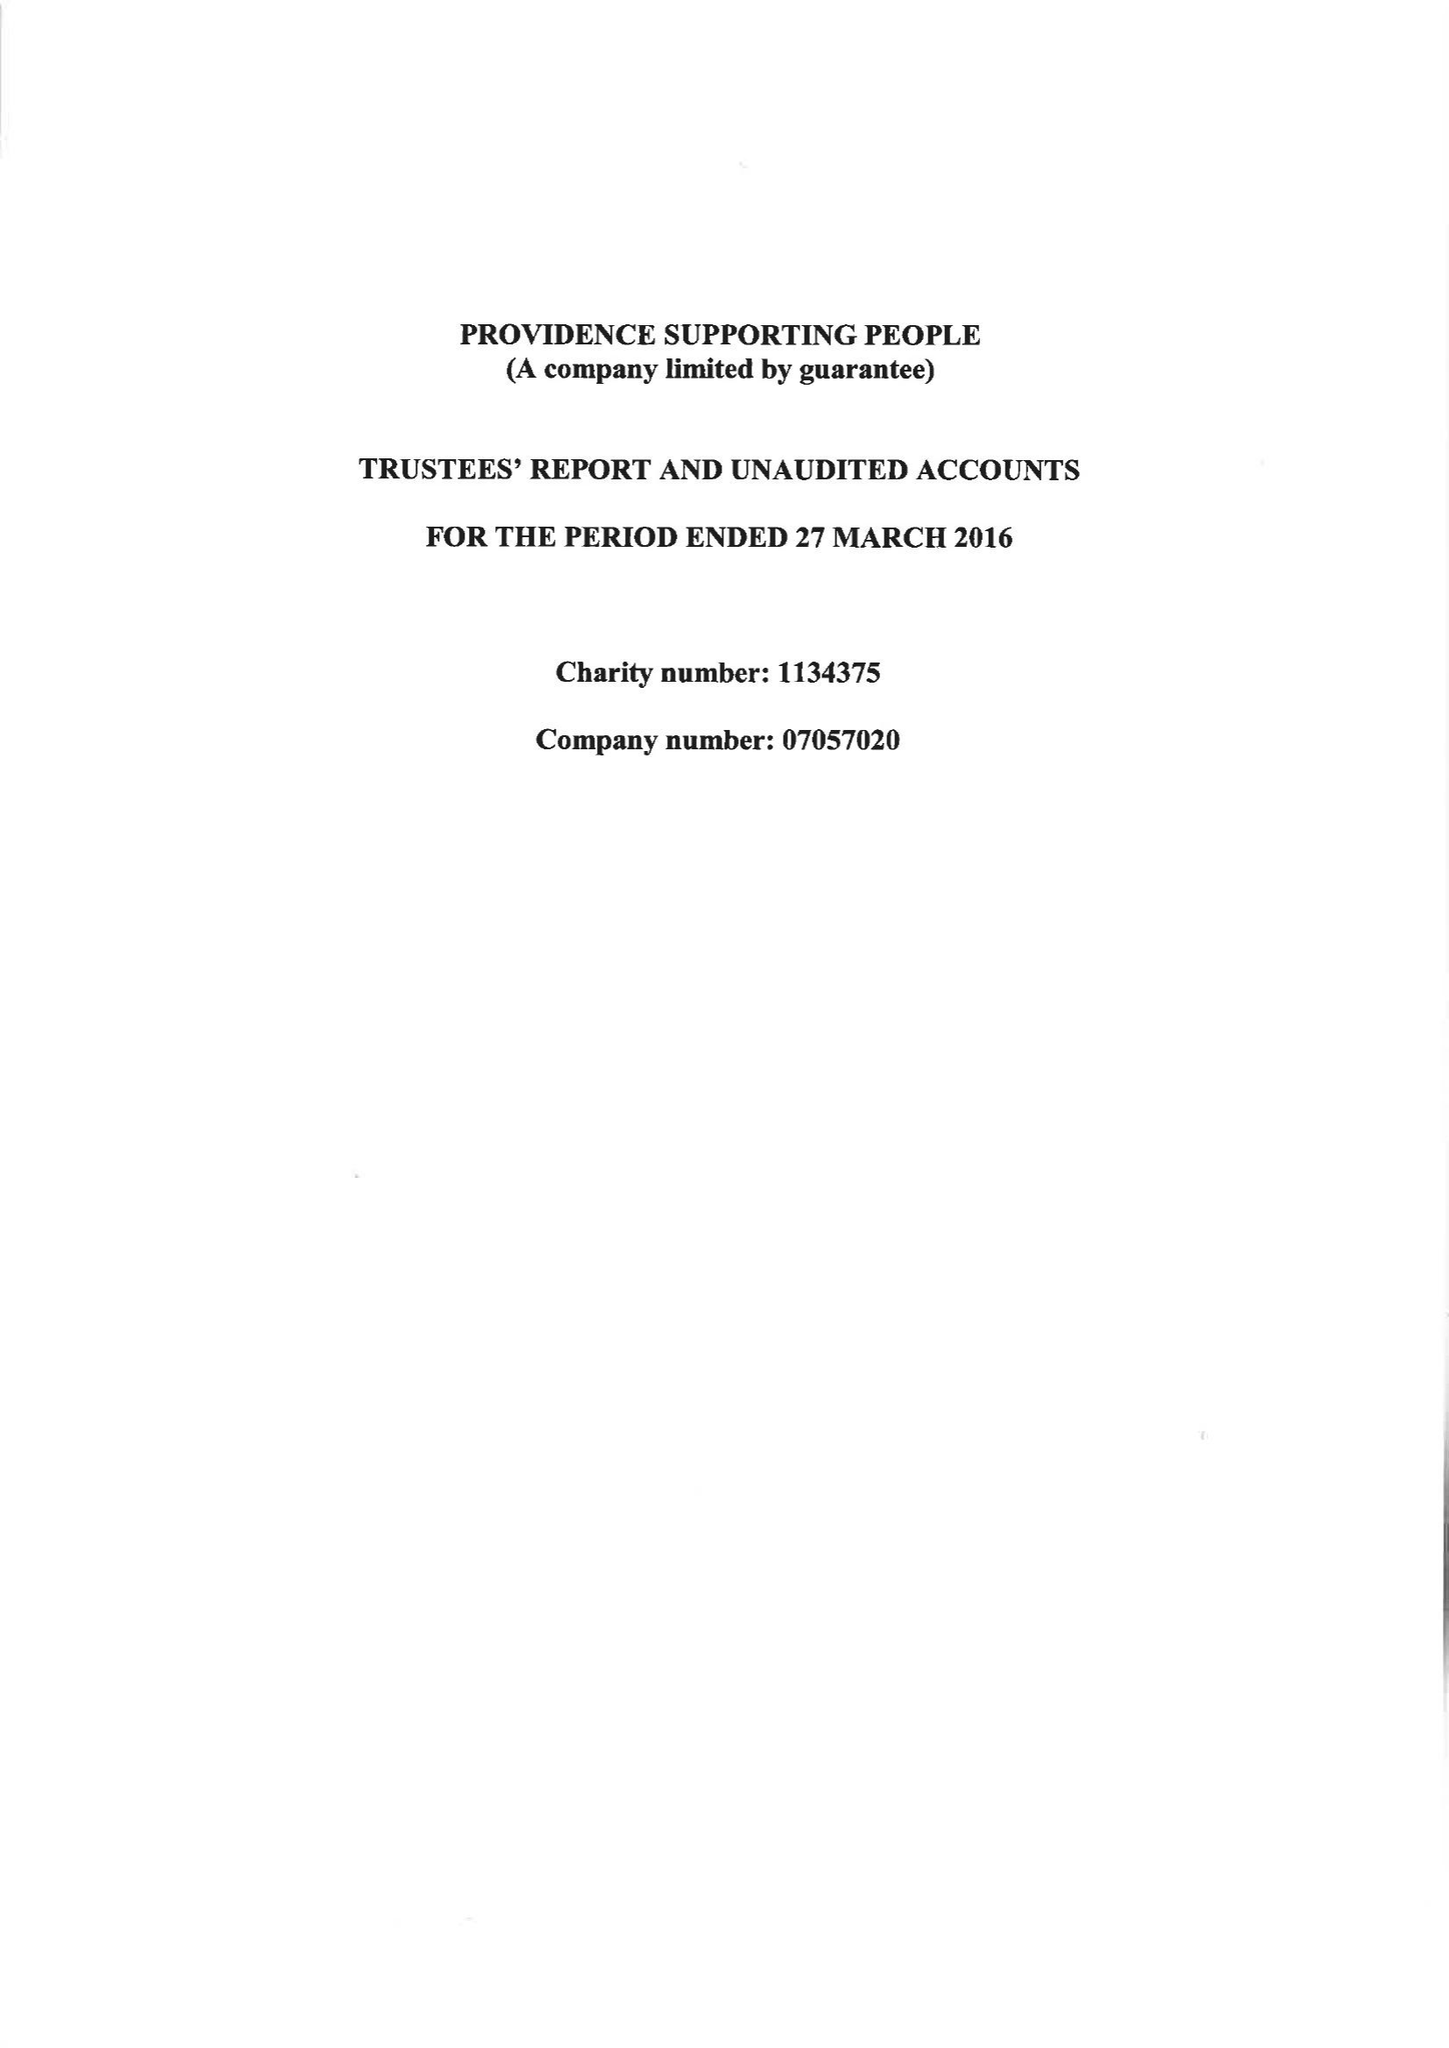What is the value for the spending_annually_in_british_pounds?
Answer the question using a single word or phrase. 257490.00 